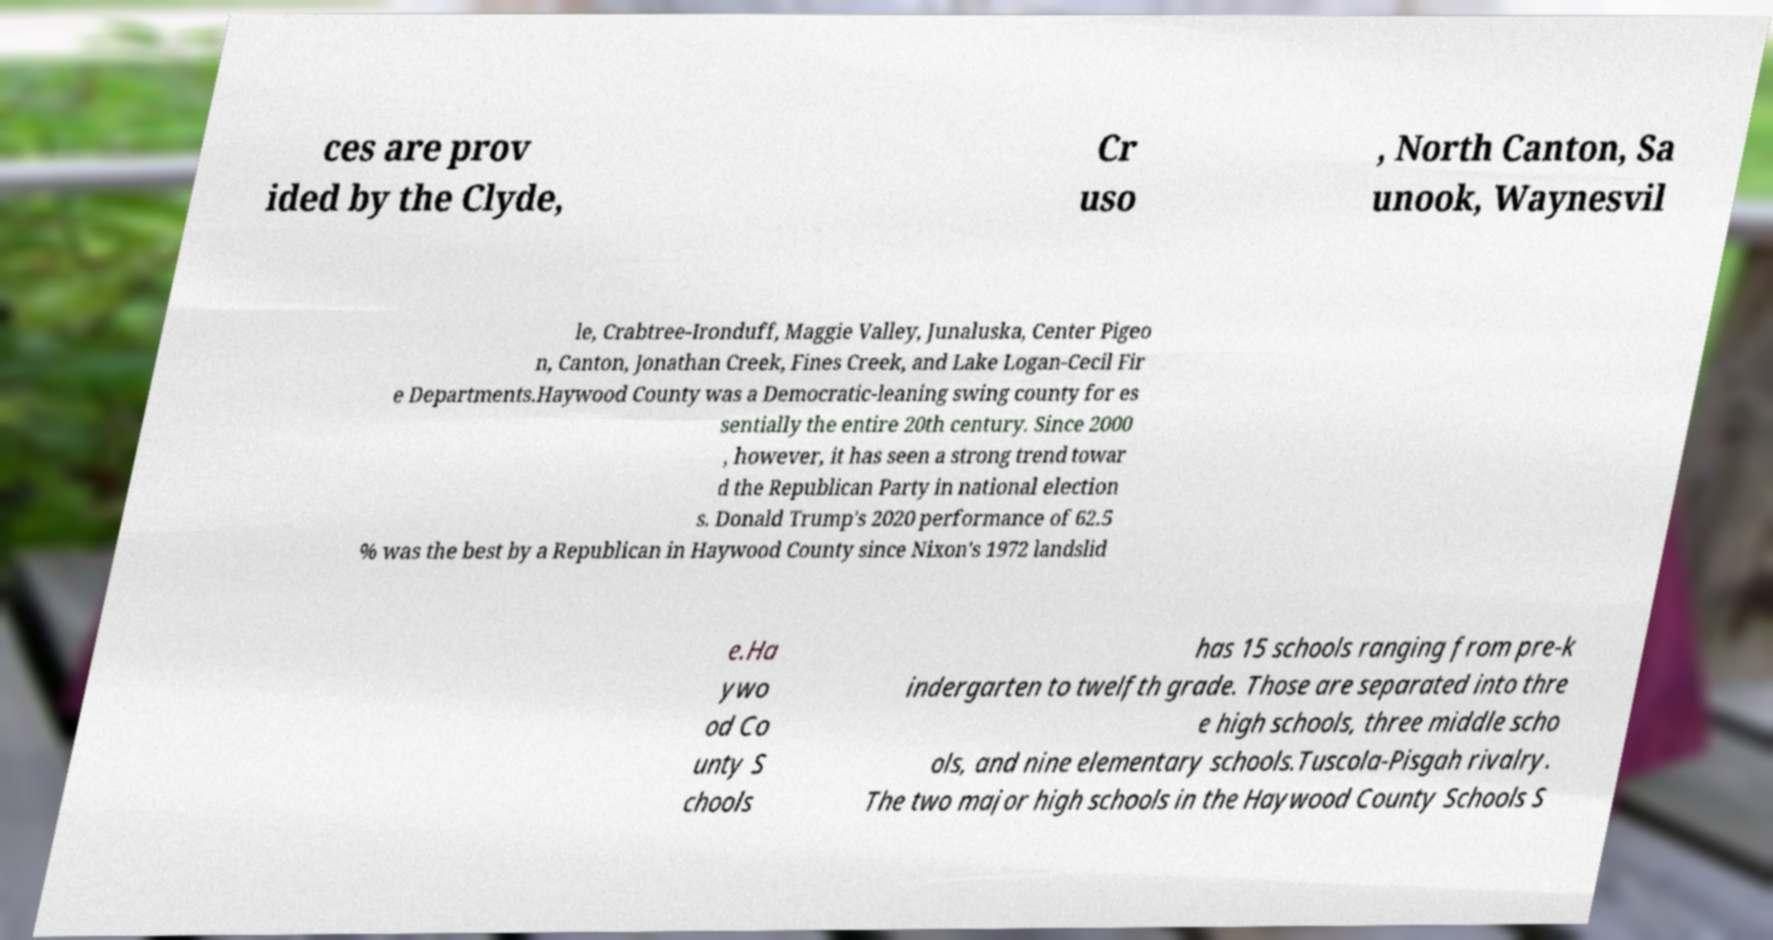For documentation purposes, I need the text within this image transcribed. Could you provide that? ces are prov ided by the Clyde, Cr uso , North Canton, Sa unook, Waynesvil le, Crabtree-Ironduff, Maggie Valley, Junaluska, Center Pigeo n, Canton, Jonathan Creek, Fines Creek, and Lake Logan-Cecil Fir e Departments.Haywood County was a Democratic-leaning swing county for es sentially the entire 20th century. Since 2000 , however, it has seen a strong trend towar d the Republican Party in national election s. Donald Trump's 2020 performance of 62.5 % was the best by a Republican in Haywood County since Nixon's 1972 landslid e.Ha ywo od Co unty S chools has 15 schools ranging from pre-k indergarten to twelfth grade. Those are separated into thre e high schools, three middle scho ols, and nine elementary schools.Tuscola-Pisgah rivalry. The two major high schools in the Haywood County Schools S 